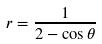<formula> <loc_0><loc_0><loc_500><loc_500>r = \frac { 1 } { 2 - \cos \theta }</formula> 